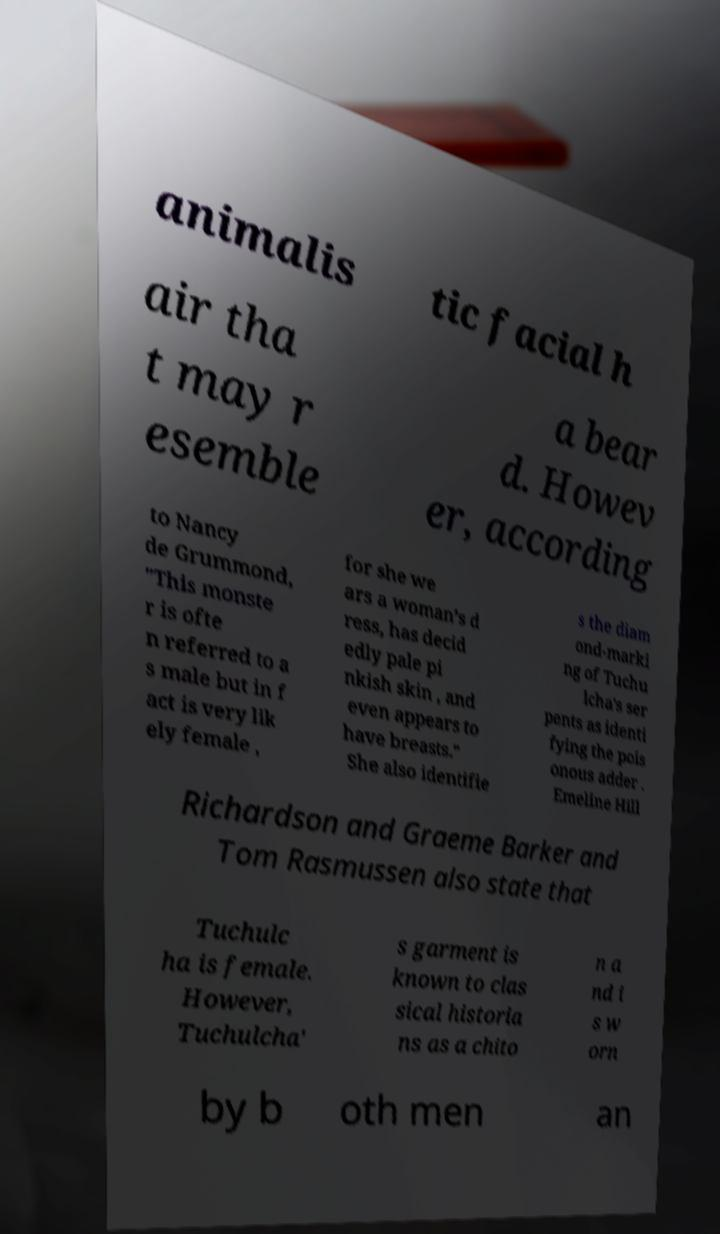What messages or text are displayed in this image? I need them in a readable, typed format. animalis tic facial h air tha t may r esemble a bear d. Howev er, according to Nancy de Grummond, "This monste r is ofte n referred to a s male but in f act is very lik ely female , for she we ars a woman’s d ress, has decid edly pale pi nkish skin , and even appears to have breasts." She also identifie s the diam ond-marki ng of Tuchu lcha's ser pents as identi fying the pois onous adder . Emeline Hill Richardson and Graeme Barker and Tom Rasmussen also state that Tuchulc ha is female. However, Tuchulcha' s garment is known to clas sical historia ns as a chito n a nd i s w orn by b oth men an 